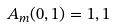Convert formula to latex. <formula><loc_0><loc_0><loc_500><loc_500>A _ { m } ( 0 , 1 ) = 1 , 1</formula> 